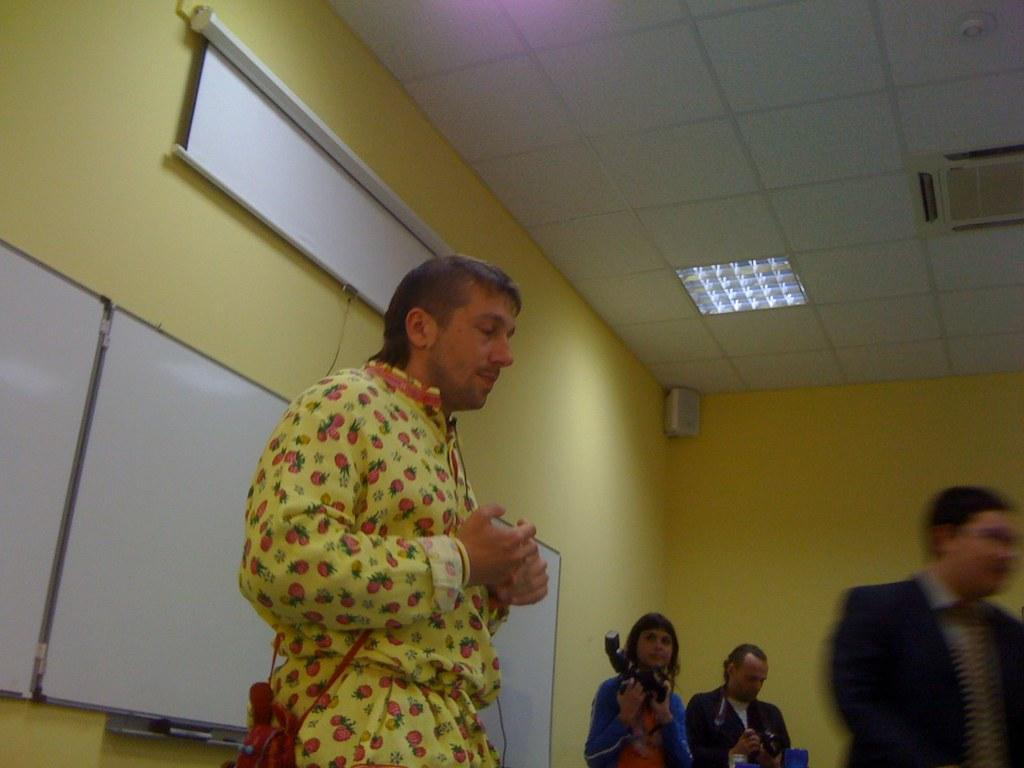What can be seen in the image involving people? There are people standing in the image. What is on the wall behind the people? There are boards and a screen on the wall behind the people. What is present on the ceiling in the image? There are lamps and a speaker on the ceiling in the image. What type of lumber is being used to build the scene in the image? There is no scene being built in the image, and no lumber is visible. How does the image convey respect among the people? The image does not convey respect among the people; it simply shows them standing in a particular setting. 